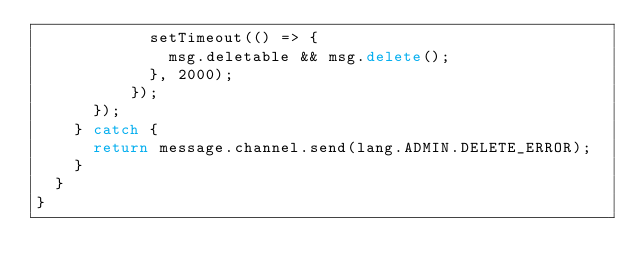Convert code to text. <code><loc_0><loc_0><loc_500><loc_500><_TypeScript_>            setTimeout(() => {
              msg.deletable && msg.delete();
            }, 2000);
          });
      });
    } catch {
      return message.channel.send(lang.ADMIN.DELETE_ERROR);
    }
  }
}
</code> 